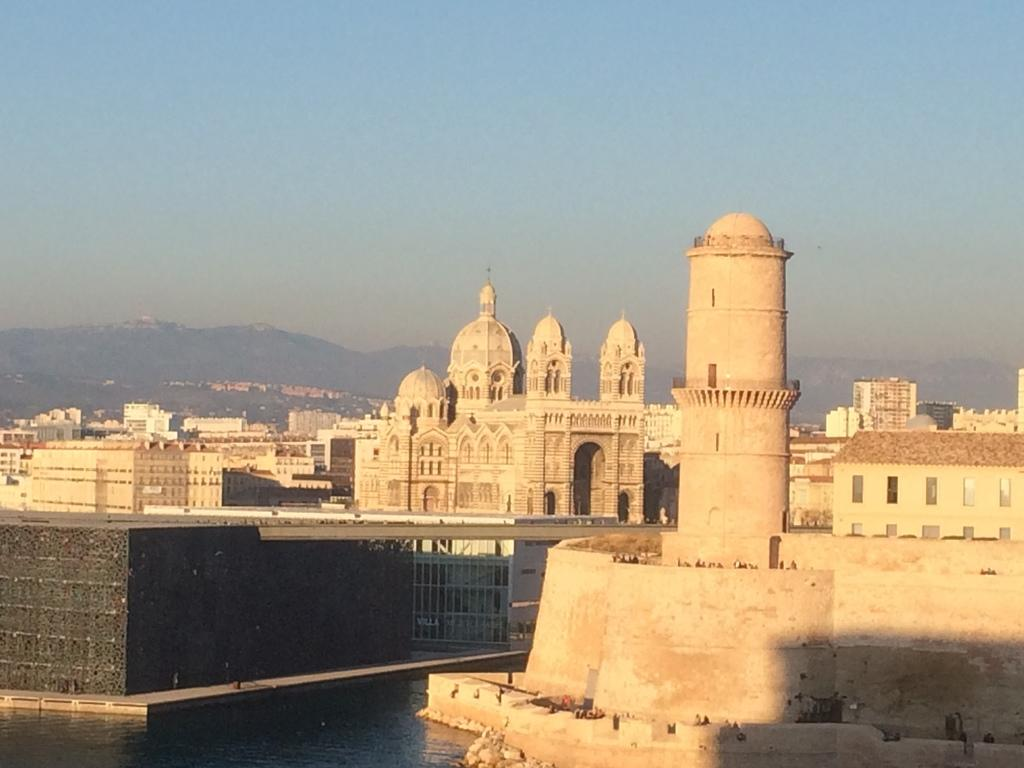What type of structures can be seen in the image? There are buildings in the image. What natural element is visible in the image? There is water visible in the image. What type of geographical feature can be seen in the background of the image? There are hills in the background of the image. What part of the natural environment is visible in the image? The sky is visible in the background of the image. What type of adjustment can be seen being made to the duck in the image? There is no duck present in the image, so no adjustment can be observed. What type of reward is being given to the buildings in the image? There is no reward being given to the buildings in the image; they are stationary structures. 